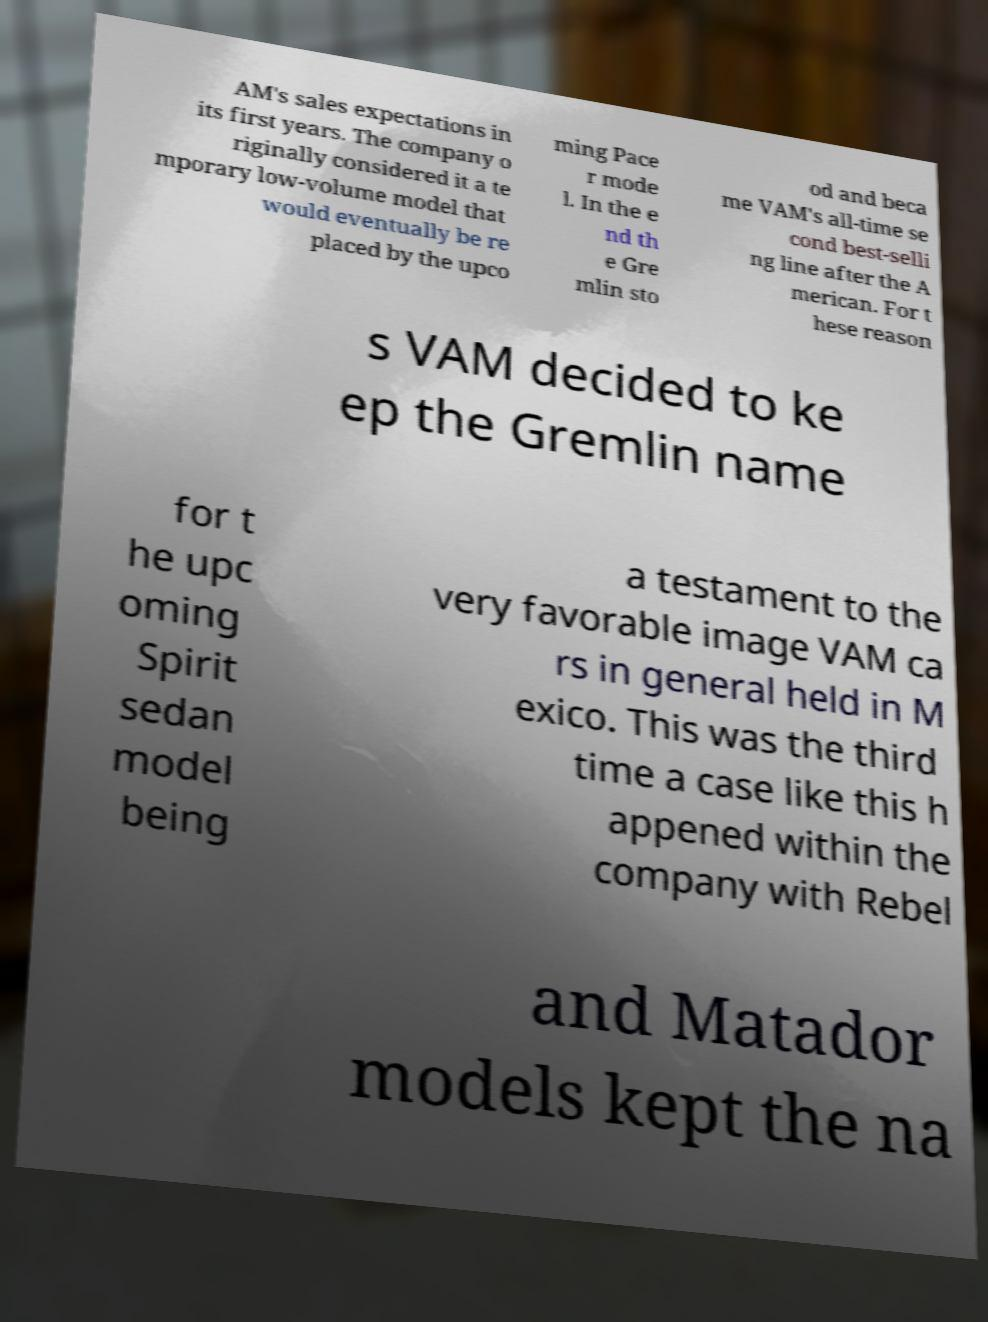What messages or text are displayed in this image? I need them in a readable, typed format. AM's sales expectations in its first years. The company o riginally considered it a te mporary low-volume model that would eventually be re placed by the upco ming Pace r mode l. In the e nd th e Gre mlin sto od and beca me VAM's all-time se cond best-selli ng line after the A merican. For t hese reason s VAM decided to ke ep the Gremlin name for t he upc oming Spirit sedan model being a testament to the very favorable image VAM ca rs in general held in M exico. This was the third time a case like this h appened within the company with Rebel and Matador models kept the na 